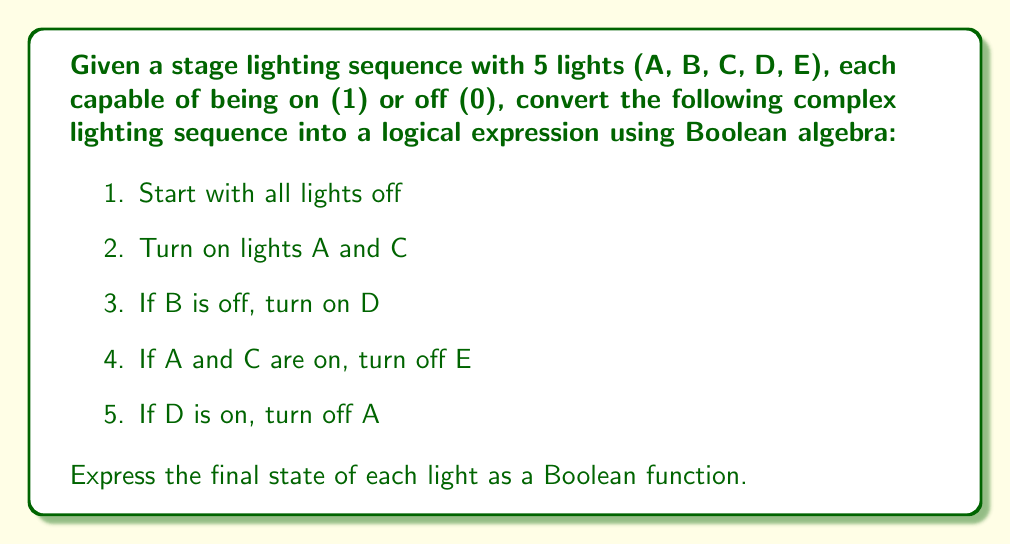Give your solution to this math problem. Let's break this down step-by-step:

1. Initially, all lights are off: $A=B=C=D=E=0$

2. Turn on lights A and C:
   $A=1, C=1$

3. If B is off, turn on D:
   This can be expressed as: $D = \overline{B}$
   Since B is still off (0), D becomes 1

4. If A and C are on, turn off E:
   This can be expressed as: $E = \overline{(A \land C)}$
   Since A and C are both on, E becomes 0

5. If D is on, turn off A:
   This can be expressed as: $A = A \land \overline{D}$
   Since D is on (1), A becomes 0

Now, let's express each light's final state as a Boolean function:

$A = 1 \land \overline{(\overline{B})} = \overline{\overline{B}}$

$B$ remains unchanged, so $B = B$

$C$ remains on, so $C = 1$

$D = \overline{B}$

$E = \overline{(1 \land 1)} = 0$

Simplifying:
$A = B$
$B = B$
$C = 1$
$D = \overline{B}$
$E = 0$
Answer: The final Boolean functions for each light:
$A = B$
$B = B$
$C = 1$
$D = \overline{B}$
$E = 0$ 